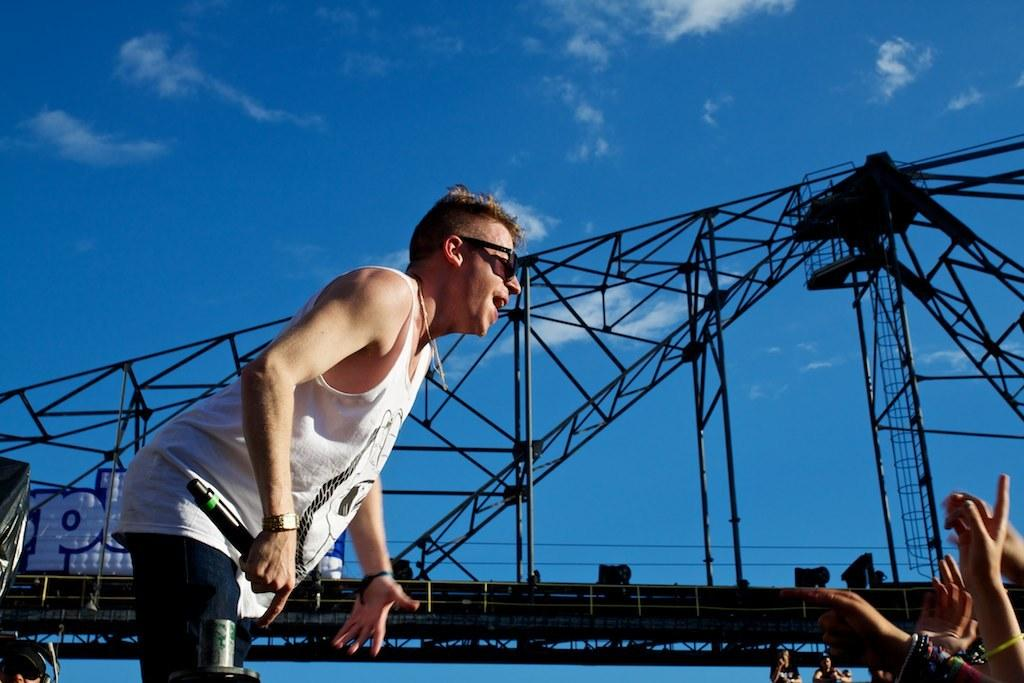What is the man in the center of the image holding? The man is holding a mic in the center of the image. What can be seen at the bottom right corner of the image? There are hands visible at the bottom right corner of the image. What is in the background of the image? There is a bridge and the sky visible in the background of the image. What can be observed in the sky in the image? Clouds are present in the background of the image. What type of plants can be seen growing near the sea in the image? There is no sea or plants visible in the image. 